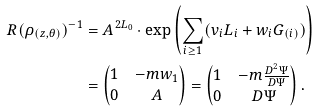Convert formula to latex. <formula><loc_0><loc_0><loc_500><loc_500>R ( \rho _ { ( z , \theta ) } ) ^ { - 1 } & = A ^ { 2 L _ { 0 } } \cdot \exp \left ( \sum _ { i \geq 1 } ( v _ { i } L _ { i } + w _ { i } G _ { ( i ) } ) \right ) \\ & = \begin{pmatrix} 1 & - m w _ { 1 } \\ 0 & A \end{pmatrix} = \begin{pmatrix} 1 & - m \frac { D ^ { 2 } \Psi } { D \Psi } \\ 0 & D \Psi \end{pmatrix} .</formula> 